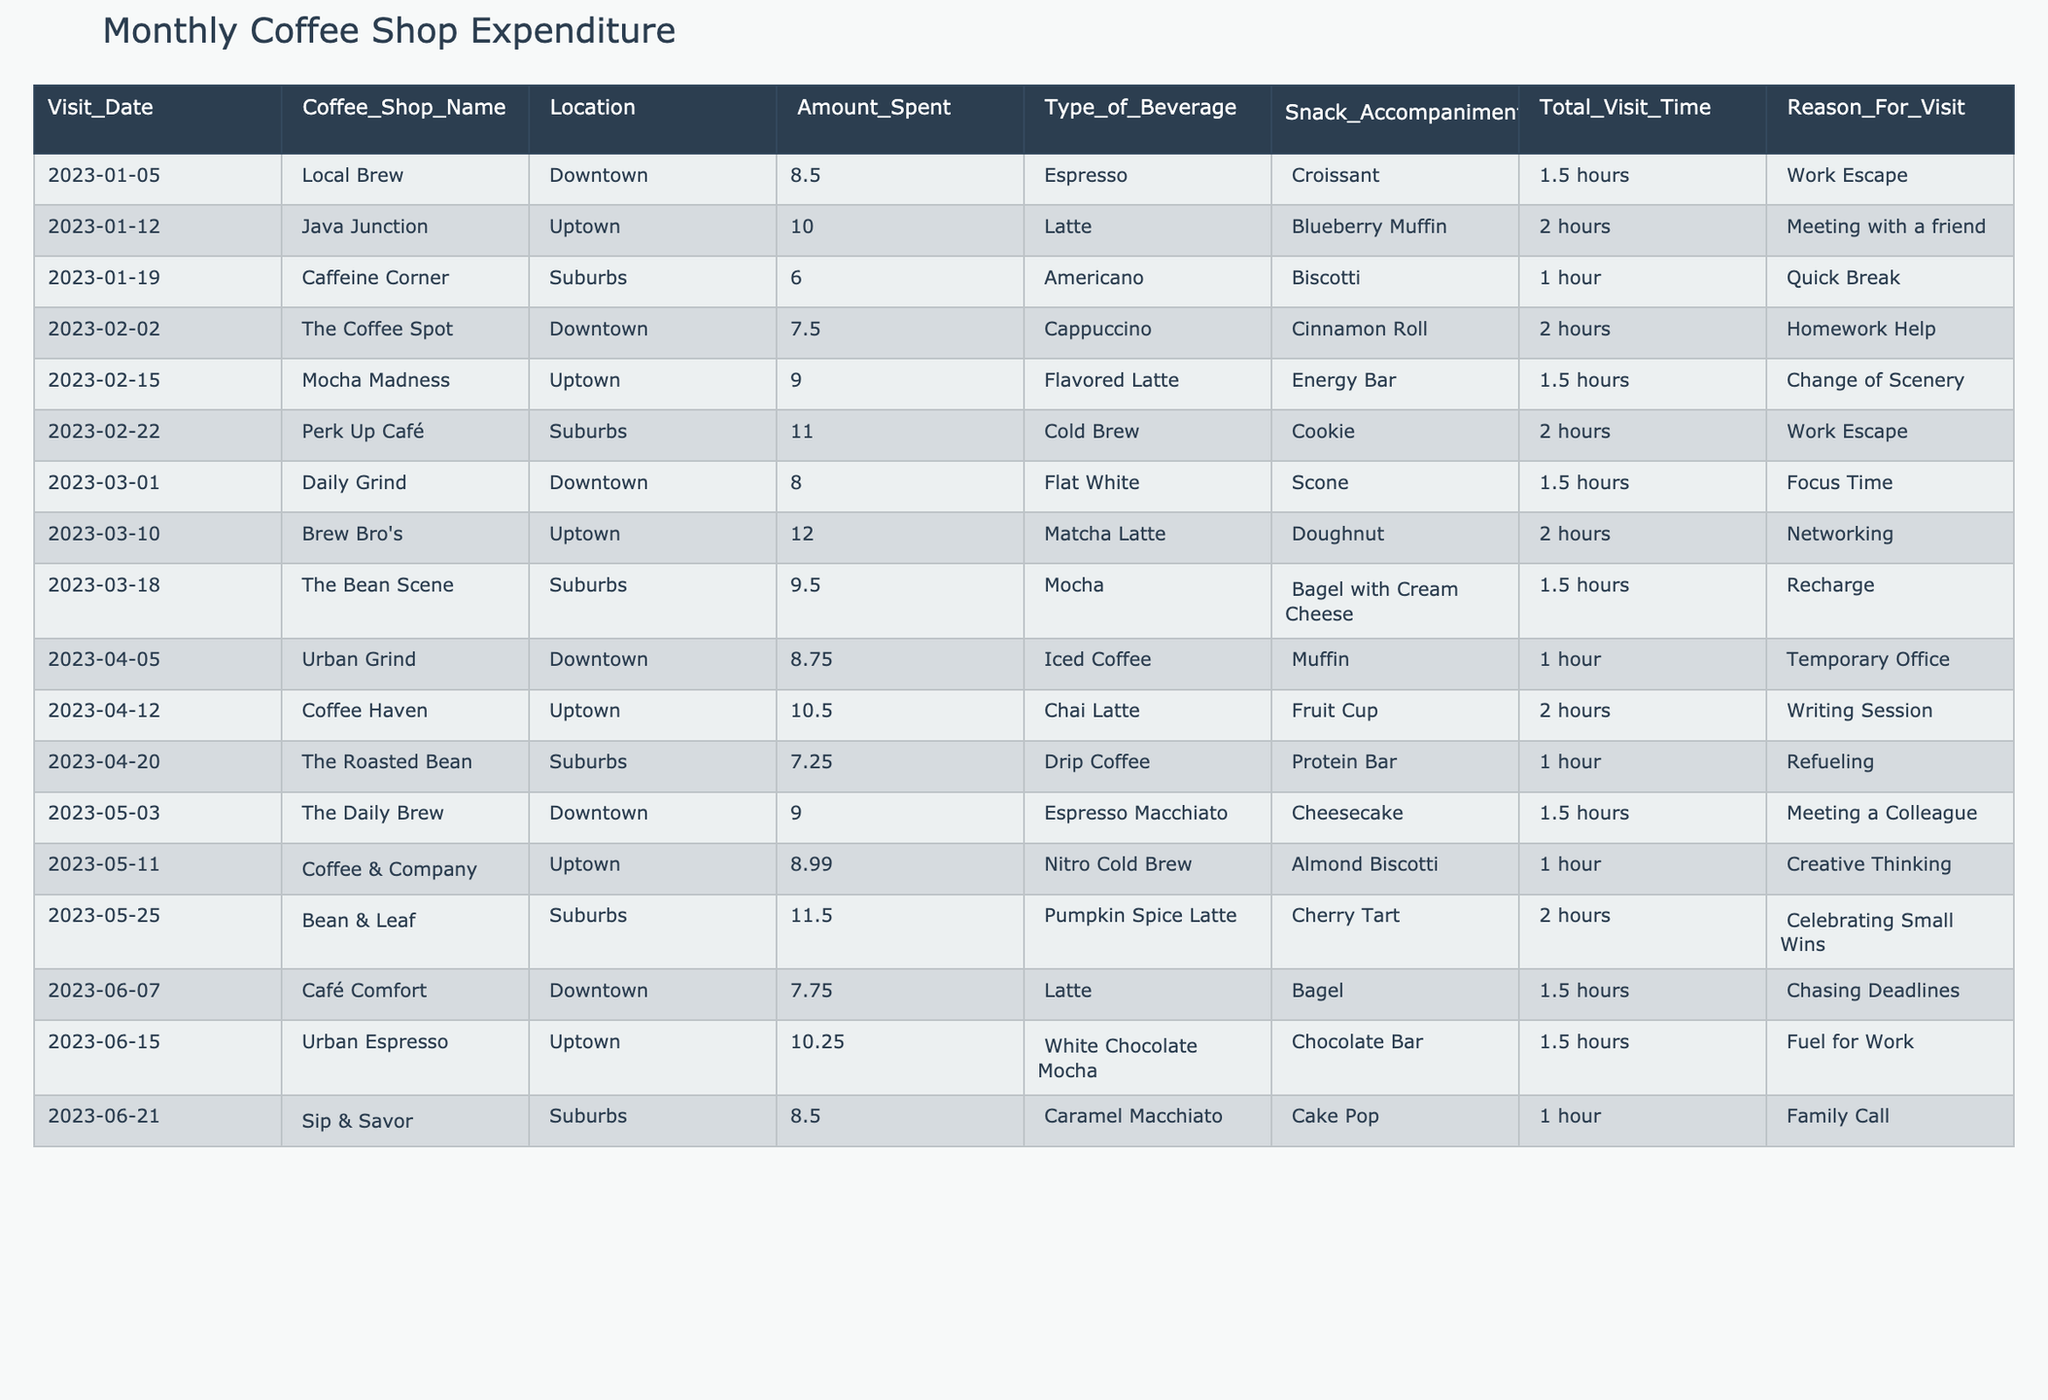What is the total amount spent on coffee shop visits in February 2023? In February, the amounts spent are 7.50, 9.00, 11.00. Summing these gives 7.50 + 9.00 + 11.00 = 27.50. Therefore, the total amount spent in that month is 27.50.
Answer: 27.50 Which coffee shop had the highest individual expense? Looking through the table, the highest expense is at Brew Bro's with an amount of 12.00.
Answer: Brew Bro's How many visits were categorized as "Work Escape"? By examining the "Reason For Visit" column, "Work Escape" appears in two rows (the visits on 2023-01-05 and 2023-02-22). Therefore, there are 2 visits classified under this category.
Answer: 2 What is the average amount spent per visit in March 2023? The amounts spent in March are 8.00, 12.00, and 9.50. Adding these amounts gives 8.00 + 12.00 + 9.50 = 29.50. Since there are 3 visits, the average is 29.50 / 3 = 9.83.
Answer: 9.83 Did every visit in January involve a snack accompaniment? By checking each entry in January, all visits (Local Brew, Java Junction, Caffeine Corner) have associated snacks. Therefore, it is true that all January visits included snacks.
Answer: Yes Which coffee shop has the average highest amount spent per visit based on the visits in 2023? To determine this, we find the average amounts spent at each coffee shop. Local Brew (8.50), Java Junction (10.00), Caffeine Corner (6.00), and so on. Summing up the respective values and dividing by the number of visits gives the averages. After calculating, Java Junction has the highest average of all shops at 10.00.
Answer: Java Junction 